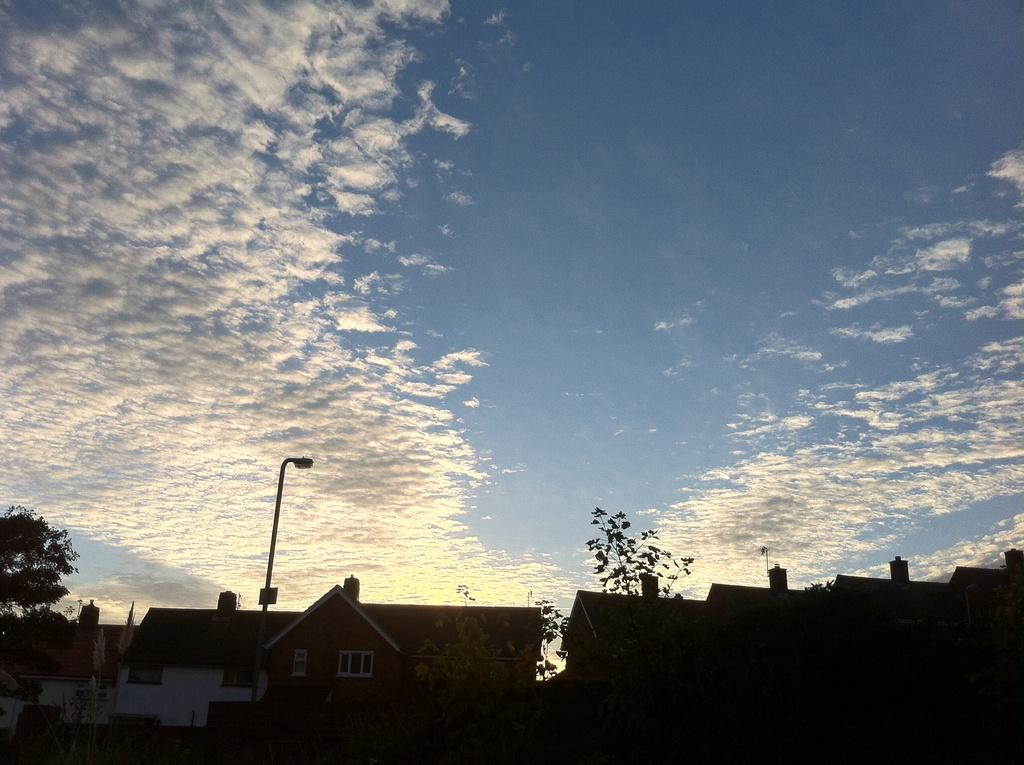What type of structures can be seen in the image? There are buildings in the image. What type of lighting is present in the image? There is a street light in the image. What type of vegetation is present in the image? There are trees in the image. What can be seen in the background of the image? The sky is visible in the background of the image. What type of soda is being taught by the servant in the image? There is no soda or servant present in the image. What type of teaching is happening in the image? There is no teaching happening in the image; it features buildings, a street light, trees, and the sky. 